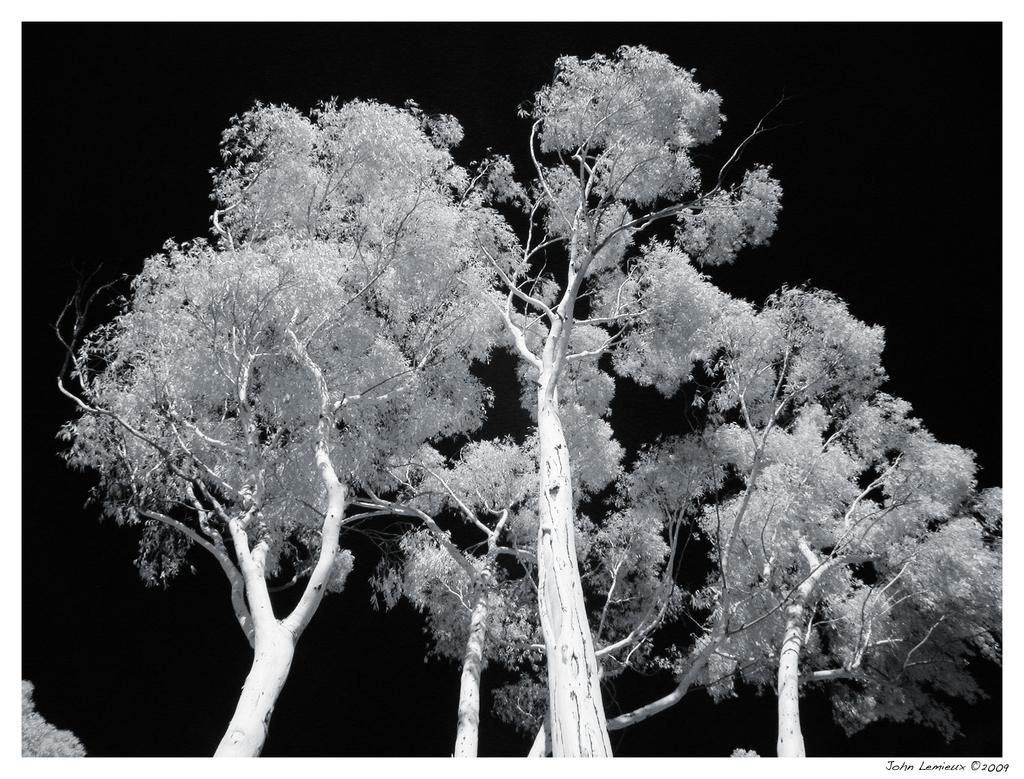What is the color scheme of the image? The image is black and white. What type of natural elements can be seen in the image? There are trees in the image. What season is depicted in the image? The image does not depict a specific season, as it is in black and white. Can you tell me how many children are playing during recess in the image? There are no children or any indication of a recess in the image; it only features trees. 